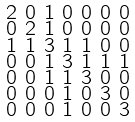<formula> <loc_0><loc_0><loc_500><loc_500>\begin{smallmatrix} 2 & 0 & 1 & 0 & 0 & 0 & 0 \\ 0 & 2 & 1 & 0 & 0 & 0 & 0 \\ 1 & 1 & 3 & 1 & 1 & 0 & 0 \\ 0 & 0 & 1 & 3 & 1 & 1 & 1 \\ 0 & 0 & 1 & 1 & 3 & 0 & 0 \\ 0 & 0 & 0 & 1 & 0 & 3 & 0 \\ 0 & 0 & 0 & 1 & 0 & 0 & 3 \end{smallmatrix}</formula> 